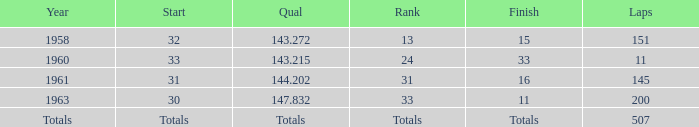In which year did the 31st rank occur? 1961.0. 